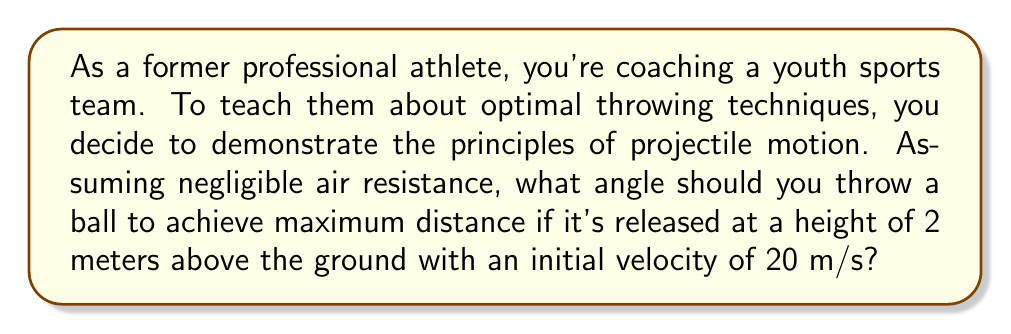Solve this math problem. To solve this problem, we need to consider the principles of projectile motion and the effect of the initial height on the optimal launch angle. Let's approach this step-by-step:

1) In general, for a projectile launched from ground level, the optimal angle for maximum range is 45°. However, when the projectile is launched from a height, the optimal angle is slightly less than 45°.

2) The range (R) of a projectile launched from a height (h) with initial velocity (v) at an angle (θ) is given by:

   $$R = \frac{v \cos θ}{g} \left(v \sin θ + \sqrt{v^2 \sin^2 θ + 2gh}\right)$$

   where g is the acceleration due to gravity (9.8 m/s²).

3) To find the optimal angle, we need to differentiate R with respect to θ and set it to zero:

   $$\frac{dR}{dθ} = 0$$

4) This leads to a complex equation. However, we can use an approximation for the optimal angle when launching from a height:

   $$θ_{opt} ≈ 45° - \frac{1}{2} \tan^{-1}\left(\frac{3gh}{v^2}\right)$$

5) Let's plug in our values:
   h = 2 m
   v = 20 m/s
   g = 9.8 m/s²

   $$θ_{opt} ≈ 45° - \frac{1}{2} \tan^{-1}\left(\frac{3 * 9.8 * 2}{20^2}\right)$$

6) Calculating this:
   $$θ_{opt} ≈ 45° - \frac{1}{2} \tan^{-1}(0.147)$$
   $$θ_{opt} ≈ 45° - 2.11°$$
   $$θ_{opt} ≈ 42.89°$$

Therefore, to achieve maximum distance, you should throw the ball at an angle of approximately 42.89° from the horizontal.
Answer: 42.89° 